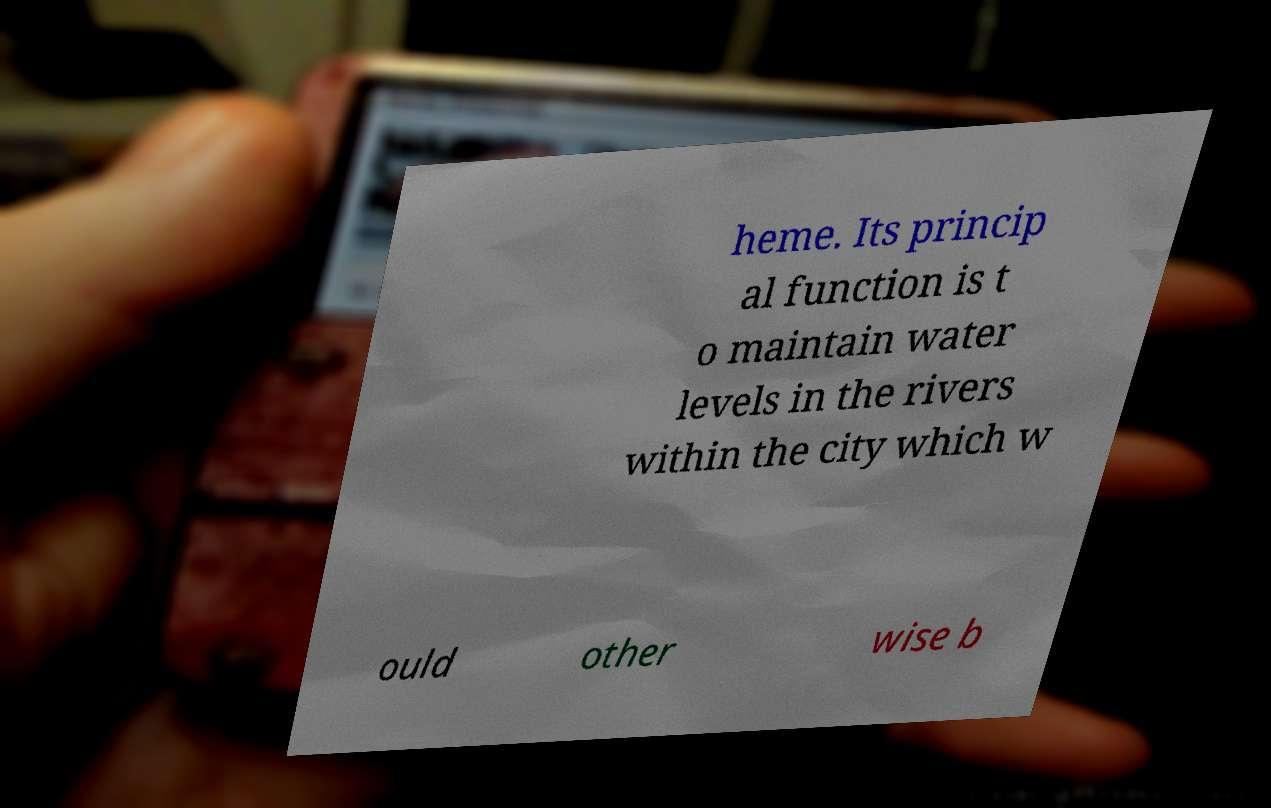Can you read and provide the text displayed in the image?This photo seems to have some interesting text. Can you extract and type it out for me? heme. Its princip al function is t o maintain water levels in the rivers within the city which w ould other wise b 